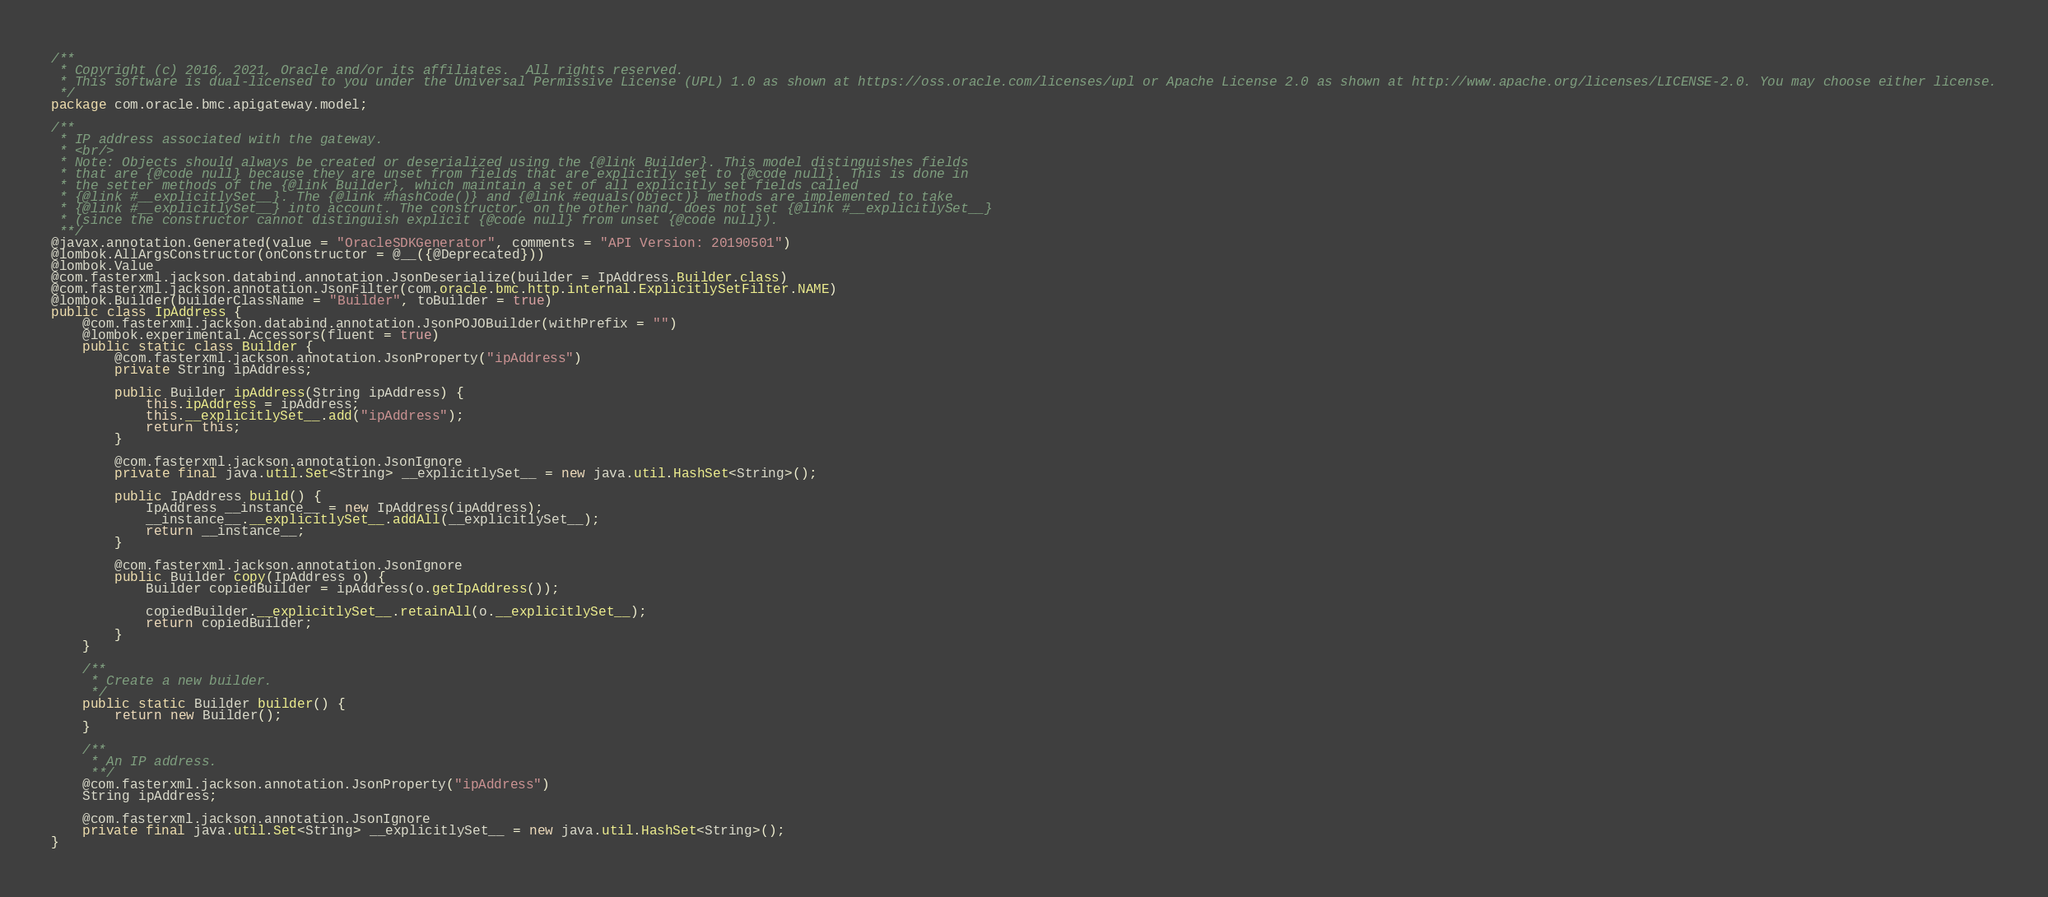Convert code to text. <code><loc_0><loc_0><loc_500><loc_500><_Java_>/**
 * Copyright (c) 2016, 2021, Oracle and/or its affiliates.  All rights reserved.
 * This software is dual-licensed to you under the Universal Permissive License (UPL) 1.0 as shown at https://oss.oracle.com/licenses/upl or Apache License 2.0 as shown at http://www.apache.org/licenses/LICENSE-2.0. You may choose either license.
 */
package com.oracle.bmc.apigateway.model;

/**
 * IP address associated with the gateway.
 * <br/>
 * Note: Objects should always be created or deserialized using the {@link Builder}. This model distinguishes fields
 * that are {@code null} because they are unset from fields that are explicitly set to {@code null}. This is done in
 * the setter methods of the {@link Builder}, which maintain a set of all explicitly set fields called
 * {@link #__explicitlySet__}. The {@link #hashCode()} and {@link #equals(Object)} methods are implemented to take
 * {@link #__explicitlySet__} into account. The constructor, on the other hand, does not set {@link #__explicitlySet__}
 * (since the constructor cannot distinguish explicit {@code null} from unset {@code null}).
 **/
@javax.annotation.Generated(value = "OracleSDKGenerator", comments = "API Version: 20190501")
@lombok.AllArgsConstructor(onConstructor = @__({@Deprecated}))
@lombok.Value
@com.fasterxml.jackson.databind.annotation.JsonDeserialize(builder = IpAddress.Builder.class)
@com.fasterxml.jackson.annotation.JsonFilter(com.oracle.bmc.http.internal.ExplicitlySetFilter.NAME)
@lombok.Builder(builderClassName = "Builder", toBuilder = true)
public class IpAddress {
    @com.fasterxml.jackson.databind.annotation.JsonPOJOBuilder(withPrefix = "")
    @lombok.experimental.Accessors(fluent = true)
    public static class Builder {
        @com.fasterxml.jackson.annotation.JsonProperty("ipAddress")
        private String ipAddress;

        public Builder ipAddress(String ipAddress) {
            this.ipAddress = ipAddress;
            this.__explicitlySet__.add("ipAddress");
            return this;
        }

        @com.fasterxml.jackson.annotation.JsonIgnore
        private final java.util.Set<String> __explicitlySet__ = new java.util.HashSet<String>();

        public IpAddress build() {
            IpAddress __instance__ = new IpAddress(ipAddress);
            __instance__.__explicitlySet__.addAll(__explicitlySet__);
            return __instance__;
        }

        @com.fasterxml.jackson.annotation.JsonIgnore
        public Builder copy(IpAddress o) {
            Builder copiedBuilder = ipAddress(o.getIpAddress());

            copiedBuilder.__explicitlySet__.retainAll(o.__explicitlySet__);
            return copiedBuilder;
        }
    }

    /**
     * Create a new builder.
     */
    public static Builder builder() {
        return new Builder();
    }

    /**
     * An IP address.
     **/
    @com.fasterxml.jackson.annotation.JsonProperty("ipAddress")
    String ipAddress;

    @com.fasterxml.jackson.annotation.JsonIgnore
    private final java.util.Set<String> __explicitlySet__ = new java.util.HashSet<String>();
}
</code> 